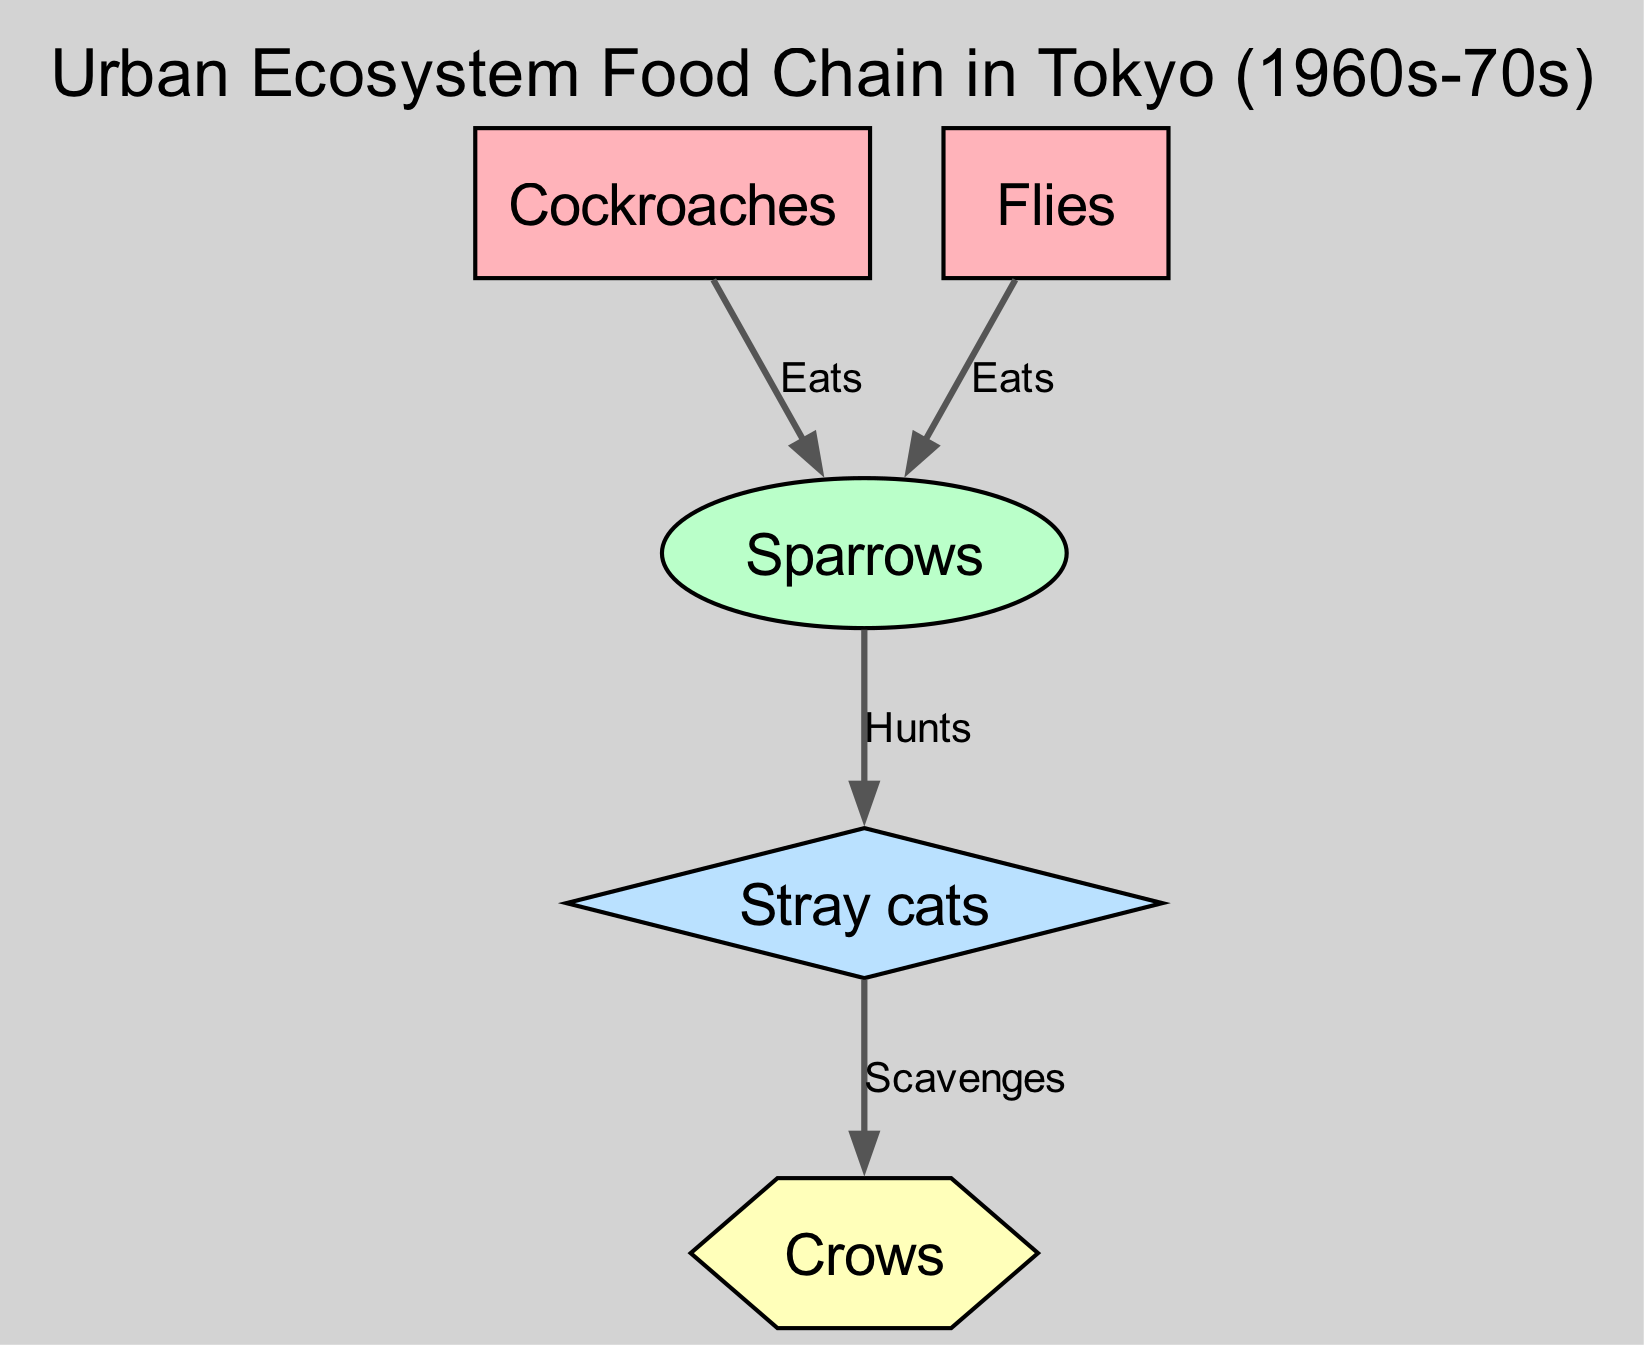What organisms are at level 1 in the food chain? The diagram indicates that there are two organisms at level 1, specifically "Cockroaches" and "Flies". Both of these organisms serve as primary consumers in the food chain.
Answer: Cockroaches, Flies How many levels are there in the food chain? The food chain diagram includes four distinct levels: 1 for Cockroaches and Flies, 2 for Sparrows, 3 for Stray cats, and 4 for Crows. Counting these levels gives us a total of four.
Answer: 4 What do Sparrows eat? According to the connections in the diagram, Sparrows feed on both "Cockroaches" and "Flies", which means those are the two food sources for Sparrows.
Answer: Cockroaches, Flies Which organism scavenges Stray cats? The diagram specifies that "Crows" are the organisms that scavenge Stray cats, showing a direct connection between them in the food chain.
Answer: Crows What is the relationship type between Sparrows and Stray cats? The connection from Sparrows to Stray cats in the diagram is labeled as "Hunts", indicating that Sparrows hunt Stray cats. This categorizes the interaction as predatory.
Answer: Hunts How many connections are in the food chain? By counting the connections listed in the diagram, we identify there are four connections: Cockroaches to Sparrows, Flies to Sparrows, Sparrows to Stray cats, and Stray cats to Crows, leading to a total of four connections.
Answer: 4 What organisms are at the highest level in the food chain? Referring to the diagram, the organism at the highest level (level 4) is "Crows", which are positioned at the top of this urban ecosystem food chain.
Answer: Crows Which organism is preyed upon by Stray cats? The diagram shows that Stray cats prey upon "Sparrows", indicating that Sparrows fall under the category of those hunted by Stray cats.
Answer: Sparrows 